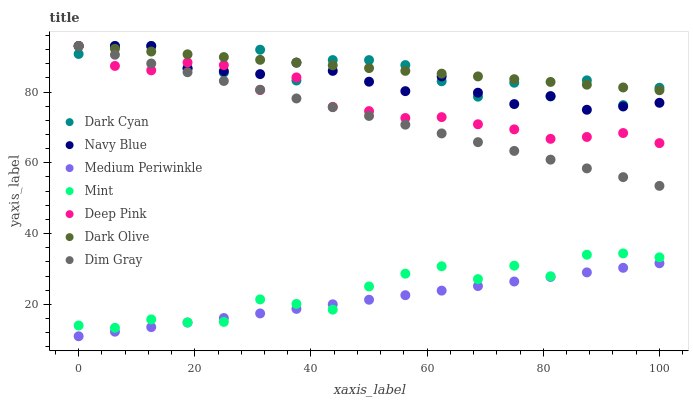Does Medium Periwinkle have the minimum area under the curve?
Answer yes or no. Yes. Does Dark Olive have the maximum area under the curve?
Answer yes or no. Yes. Does Navy Blue have the minimum area under the curve?
Answer yes or no. No. Does Navy Blue have the maximum area under the curve?
Answer yes or no. No. Is Medium Periwinkle the smoothest?
Answer yes or no. Yes. Is Dark Cyan the roughest?
Answer yes or no. Yes. Is Navy Blue the smoothest?
Answer yes or no. No. Is Navy Blue the roughest?
Answer yes or no. No. Does Medium Periwinkle have the lowest value?
Answer yes or no. Yes. Does Navy Blue have the lowest value?
Answer yes or no. No. Does Dark Cyan have the highest value?
Answer yes or no. Yes. Does Medium Periwinkle have the highest value?
Answer yes or no. No. Is Mint less than Dark Cyan?
Answer yes or no. Yes. Is Dark Olive greater than Mint?
Answer yes or no. Yes. Does Dim Gray intersect Deep Pink?
Answer yes or no. Yes. Is Dim Gray less than Deep Pink?
Answer yes or no. No. Is Dim Gray greater than Deep Pink?
Answer yes or no. No. Does Mint intersect Dark Cyan?
Answer yes or no. No. 